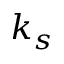<formula> <loc_0><loc_0><loc_500><loc_500>k _ { s }</formula> 